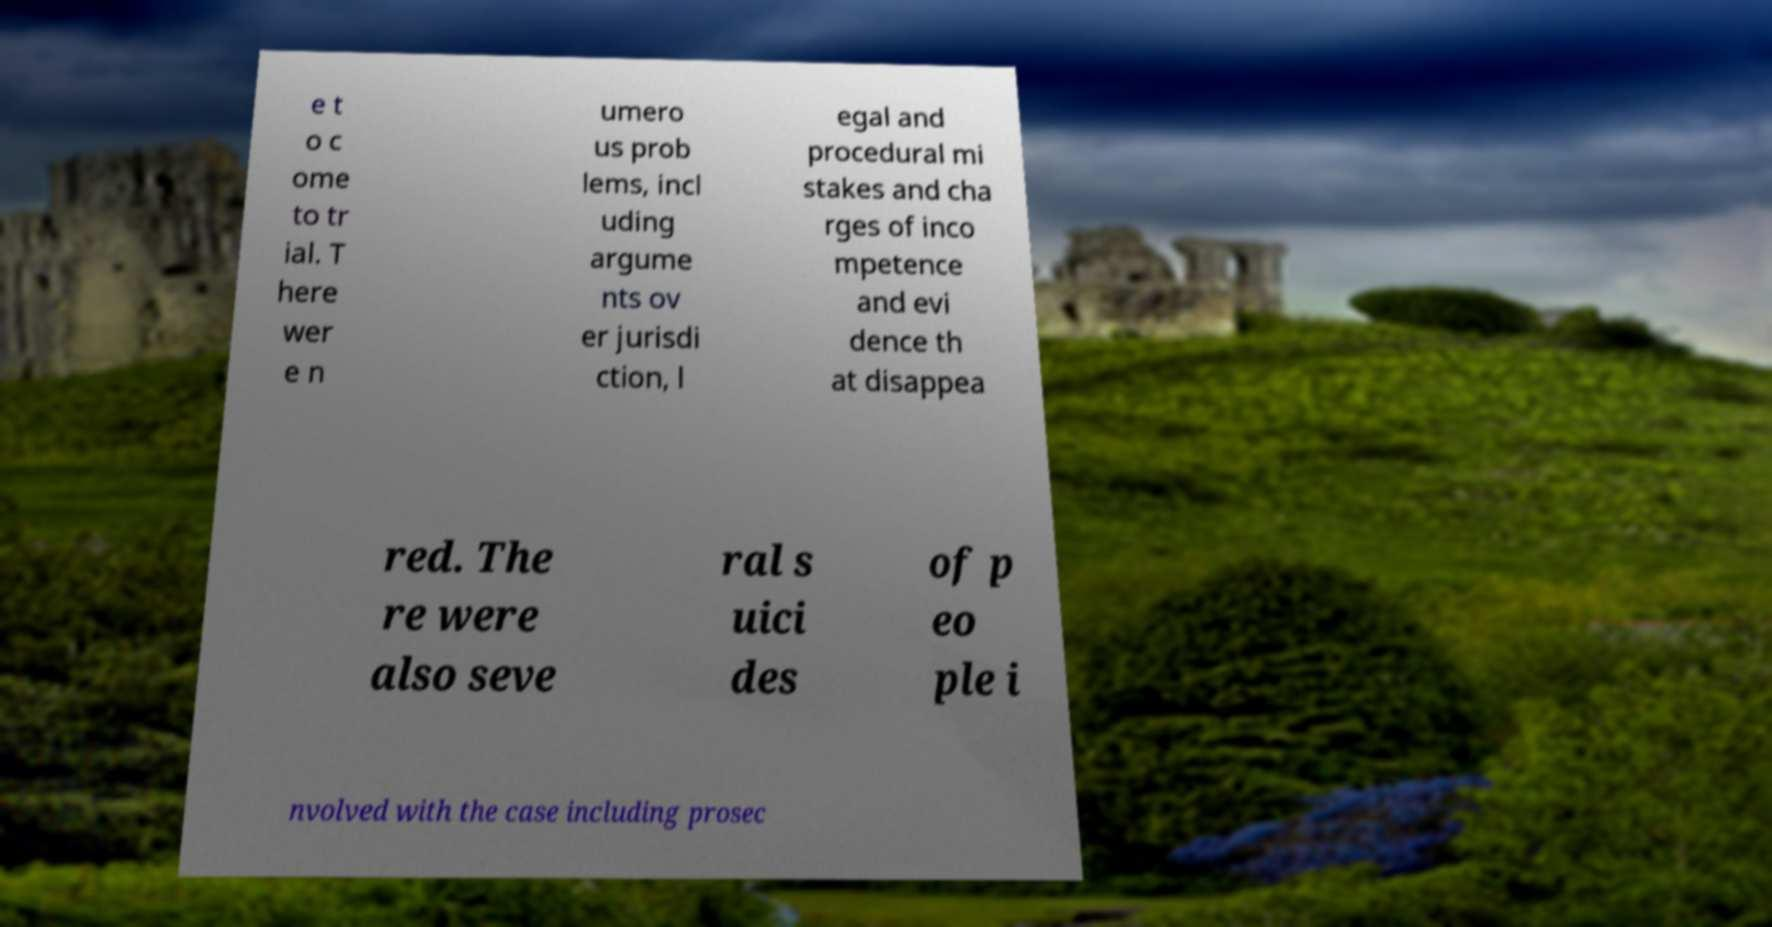For documentation purposes, I need the text within this image transcribed. Could you provide that? e t o c ome to tr ial. T here wer e n umero us prob lems, incl uding argume nts ov er jurisdi ction, l egal and procedural mi stakes and cha rges of inco mpetence and evi dence th at disappea red. The re were also seve ral s uici des of p eo ple i nvolved with the case including prosec 